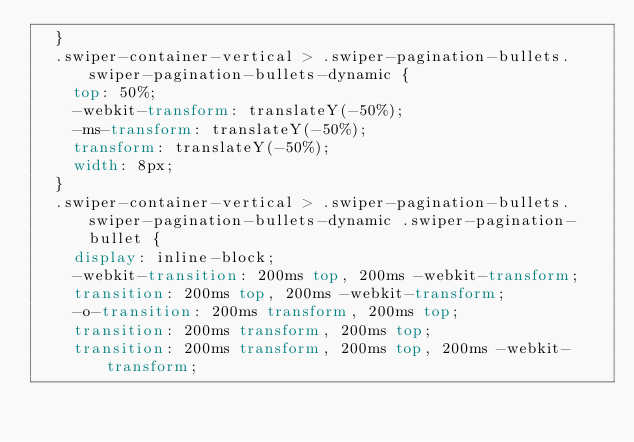<code> <loc_0><loc_0><loc_500><loc_500><_CSS_>  }
  .swiper-container-vertical > .swiper-pagination-bullets.swiper-pagination-bullets-dynamic {
    top: 50%;
    -webkit-transform: translateY(-50%);
    -ms-transform: translateY(-50%);
    transform: translateY(-50%);
    width: 8px;
  }
  .swiper-container-vertical > .swiper-pagination-bullets.swiper-pagination-bullets-dynamic .swiper-pagination-bullet {
    display: inline-block;
    -webkit-transition: 200ms top, 200ms -webkit-transform;
    transition: 200ms top, 200ms -webkit-transform;
    -o-transition: 200ms transform, 200ms top;
    transition: 200ms transform, 200ms top;
    transition: 200ms transform, 200ms top, 200ms -webkit-transform;</code> 